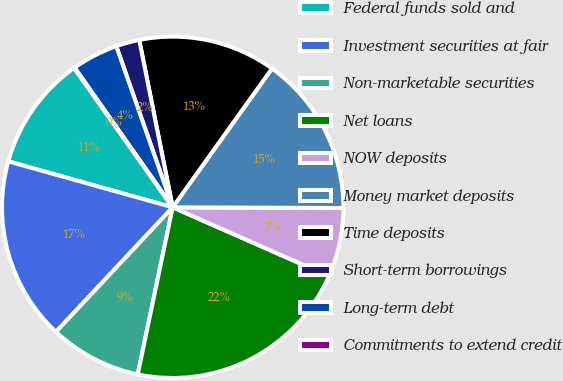Convert chart to OTSL. <chart><loc_0><loc_0><loc_500><loc_500><pie_chart><fcel>Federal funds sold and<fcel>Investment securities at fair<fcel>Non-marketable securities<fcel>Net loans<fcel>NOW deposits<fcel>Money market deposits<fcel>Time deposits<fcel>Short-term borrowings<fcel>Long-term debt<fcel>Commitments to extend credit<nl><fcel>10.86%<fcel>17.35%<fcel>8.7%<fcel>21.67%<fcel>6.54%<fcel>15.18%<fcel>13.02%<fcel>2.22%<fcel>4.38%<fcel>0.06%<nl></chart> 